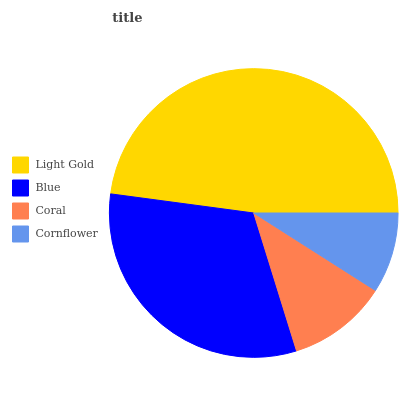Is Cornflower the minimum?
Answer yes or no. Yes. Is Light Gold the maximum?
Answer yes or no. Yes. Is Blue the minimum?
Answer yes or no. No. Is Blue the maximum?
Answer yes or no. No. Is Light Gold greater than Blue?
Answer yes or no. Yes. Is Blue less than Light Gold?
Answer yes or no. Yes. Is Blue greater than Light Gold?
Answer yes or no. No. Is Light Gold less than Blue?
Answer yes or no. No. Is Blue the high median?
Answer yes or no. Yes. Is Coral the low median?
Answer yes or no. Yes. Is Coral the high median?
Answer yes or no. No. Is Blue the low median?
Answer yes or no. No. 